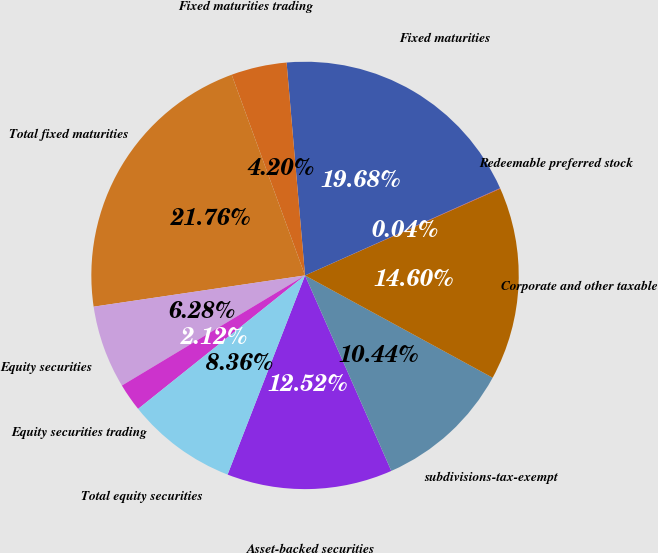Convert chart to OTSL. <chart><loc_0><loc_0><loc_500><loc_500><pie_chart><fcel>Asset-backed securities<fcel>subdivisions-tax-exempt<fcel>Corporate and other taxable<fcel>Redeemable preferred stock<fcel>Fixed maturities<fcel>Fixed maturities trading<fcel>Total fixed maturities<fcel>Equity securities<fcel>Equity securities trading<fcel>Total equity securities<nl><fcel>12.52%<fcel>10.44%<fcel>14.6%<fcel>0.04%<fcel>19.68%<fcel>4.2%<fcel>21.76%<fcel>6.28%<fcel>2.12%<fcel>8.36%<nl></chart> 